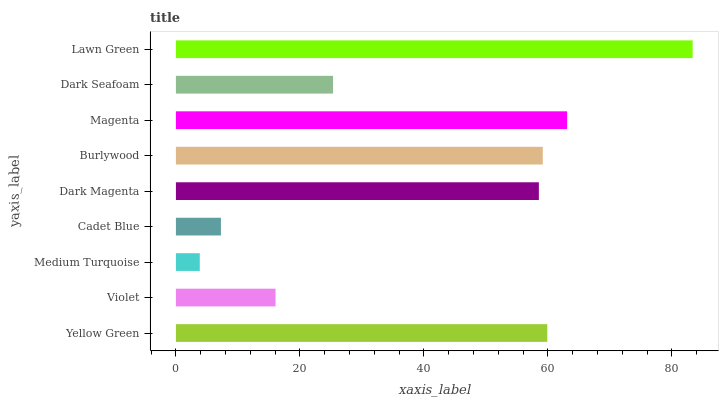Is Medium Turquoise the minimum?
Answer yes or no. Yes. Is Lawn Green the maximum?
Answer yes or no. Yes. Is Violet the minimum?
Answer yes or no. No. Is Violet the maximum?
Answer yes or no. No. Is Yellow Green greater than Violet?
Answer yes or no. Yes. Is Violet less than Yellow Green?
Answer yes or no. Yes. Is Violet greater than Yellow Green?
Answer yes or no. No. Is Yellow Green less than Violet?
Answer yes or no. No. Is Dark Magenta the high median?
Answer yes or no. Yes. Is Dark Magenta the low median?
Answer yes or no. Yes. Is Cadet Blue the high median?
Answer yes or no. No. Is Dark Seafoam the low median?
Answer yes or no. No. 